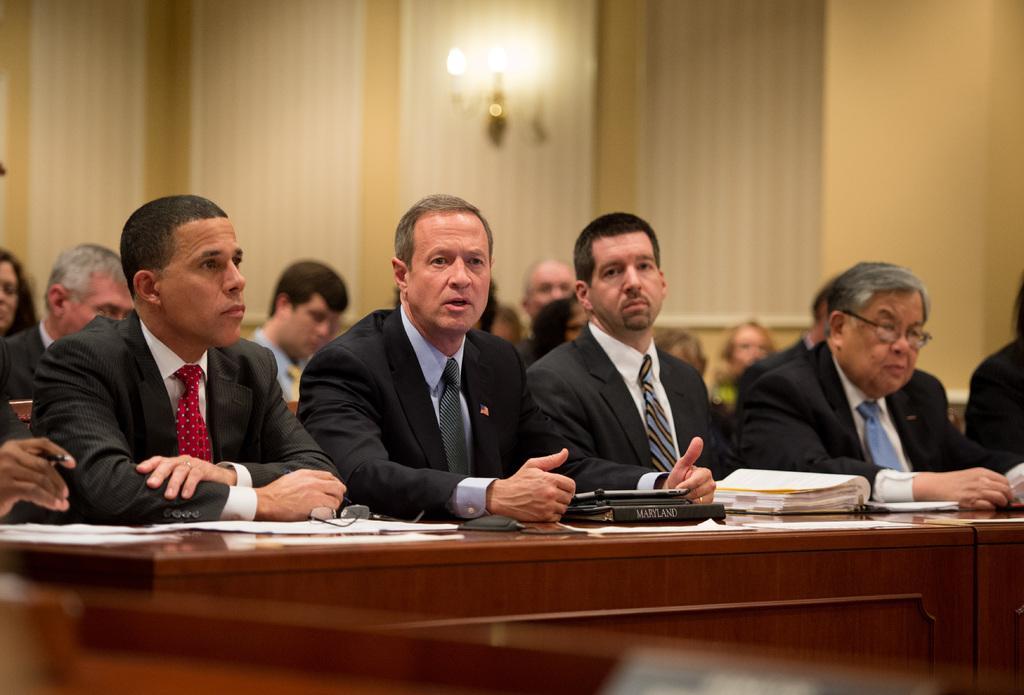Could you give a brief overview of what you see in this image? In this image, there are a few people. We can see a table with some objects like posters and spectacles. We can also see an object at the bottom. We can see the wall and a light. 